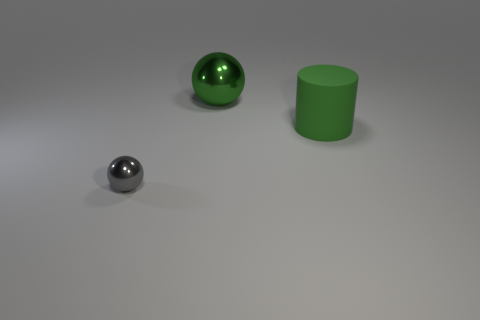Add 2 big green matte objects. How many objects exist? 5 Subtract all spheres. How many objects are left? 1 Add 3 small metal spheres. How many small metal spheres are left? 4 Add 3 large shiny spheres. How many large shiny spheres exist? 4 Subtract 0 red cylinders. How many objects are left? 3 Subtract all green objects. Subtract all large green cylinders. How many objects are left? 0 